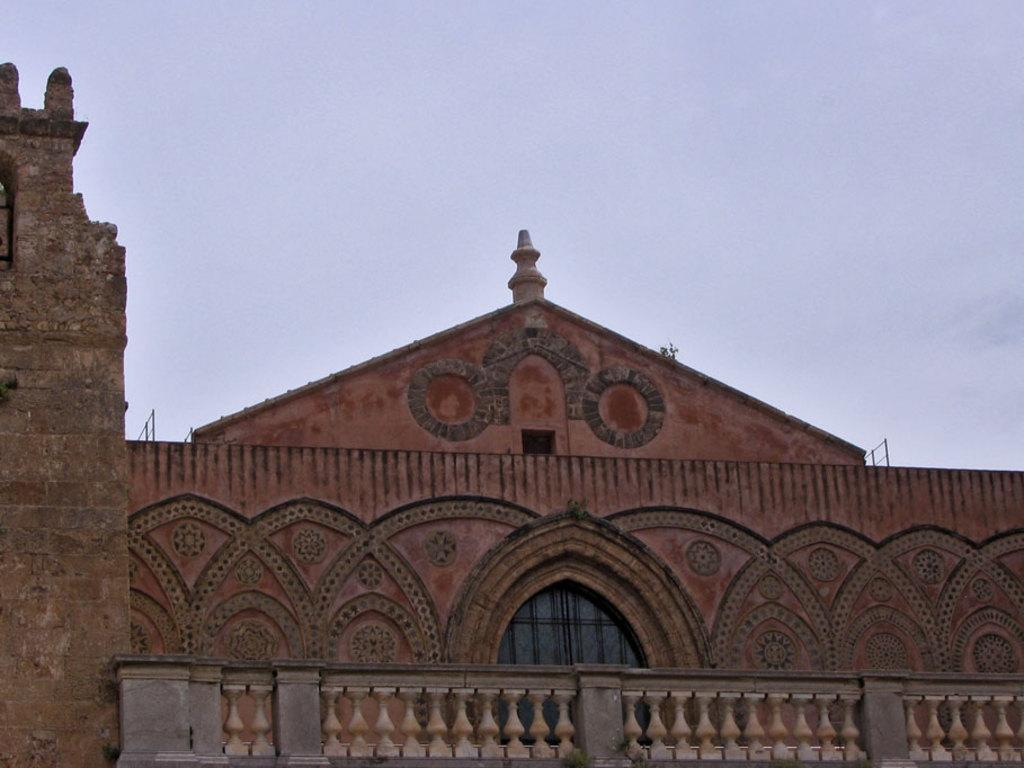What type of structure is present in the image? There is a building in the image. What feature of the building is mentioned in the facts? The building has doors. What architectural element can be seen at the bottom of the image? There is a baluster at the bottom of the image. What is visible at the top of the image? The sky is visible at the top of the image. How many clocks are hanging on the walls inside the building in the image? There is no information about clocks or the interior of the building in the provided facts, so we cannot determine the number of clocks. 